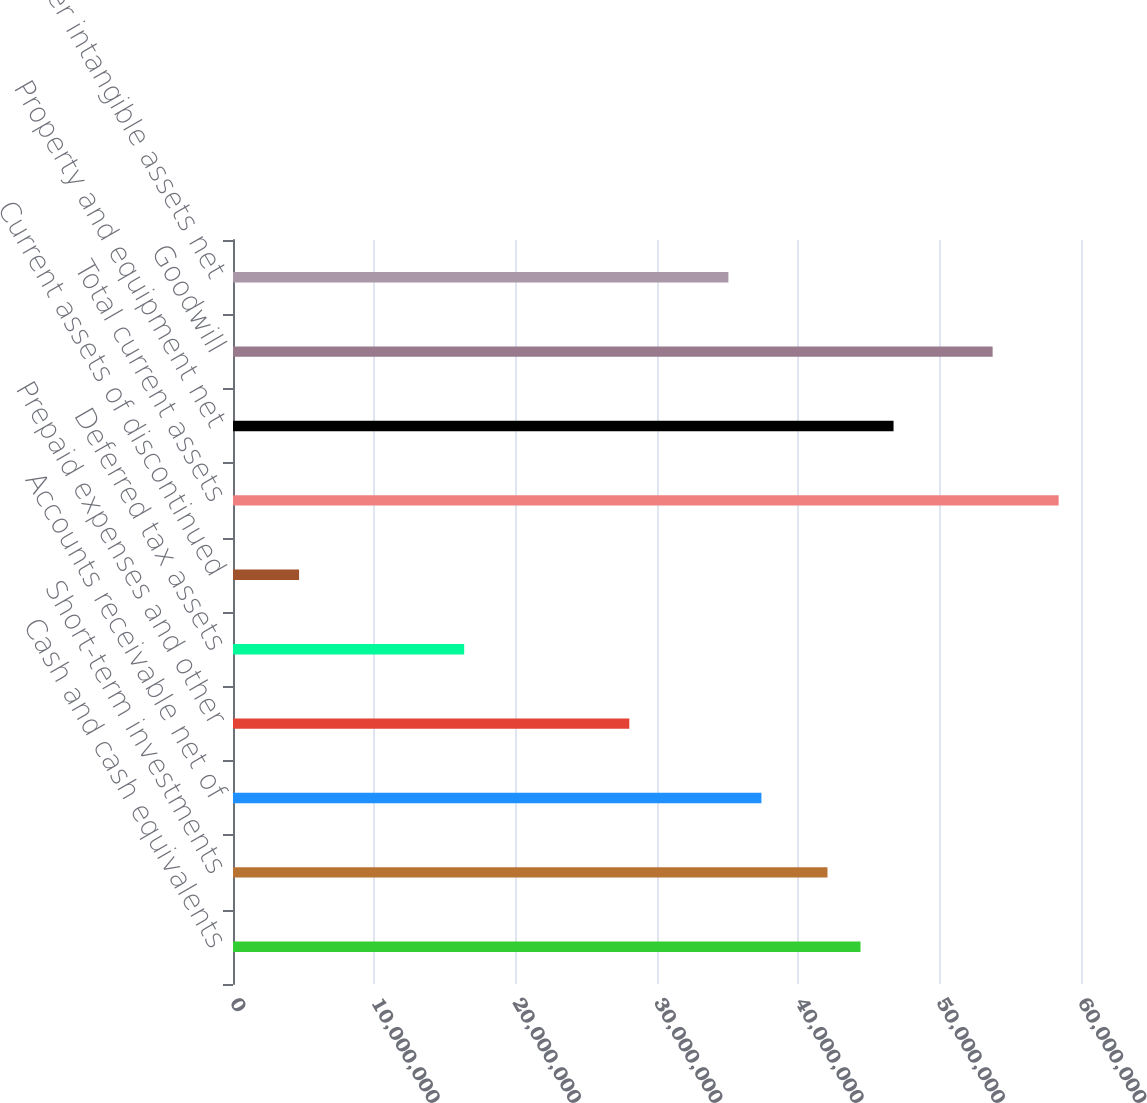Convert chart. <chart><loc_0><loc_0><loc_500><loc_500><bar_chart><fcel>Cash and cash equivalents<fcel>Short-term investments<fcel>Accounts receivable net of<fcel>Prepaid expenses and other<fcel>Deferred tax assets<fcel>Current assets of discontinued<fcel>Total current assets<fcel>Property and equipment net<fcel>Goodwill<fcel>Other intangible assets net<nl><fcel>4.43999e+07<fcel>4.2063e+07<fcel>3.73894e+07<fcel>2.80421e+07<fcel>1.6358e+07<fcel>4.67389e+06<fcel>5.84208e+07<fcel>4.67367e+07<fcel>5.37471e+07<fcel>3.50526e+07<nl></chart> 